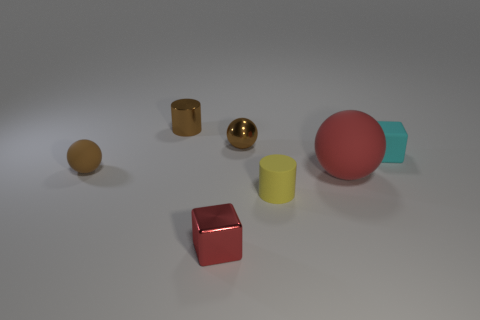Subtract all tiny brown spheres. How many spheres are left? 1 Add 3 small yellow matte balls. How many objects exist? 10 Subtract 2 cylinders. How many cylinders are left? 0 Subtract all cubes. How many objects are left? 5 Add 7 brown metal objects. How many brown metal objects are left? 9 Add 6 small yellow cylinders. How many small yellow cylinders exist? 7 Subtract all red balls. How many balls are left? 2 Subtract 1 red spheres. How many objects are left? 6 Subtract all brown spheres. Subtract all red blocks. How many spheres are left? 1 Subtract all blue spheres. How many brown blocks are left? 0 